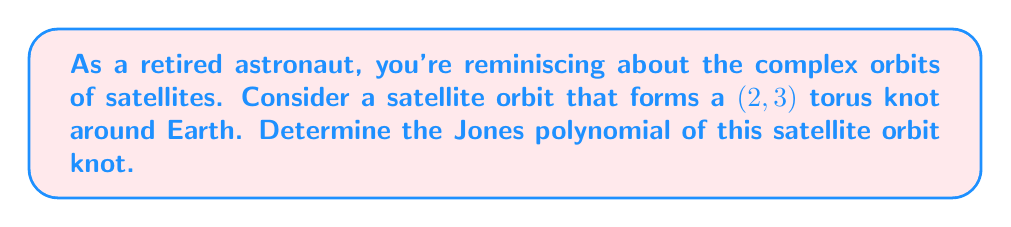Help me with this question. Let's approach this step-by-step:

1) The $(2,3)$ torus knot is also known as the trefoil knot.

2) To calculate the Jones polynomial, we'll use the skein relation:

   $$t^{-1}V(L_+) - tV(L_-) = (t^{1/2} - t^{-1/2})V(L_0)$$

   where $L_+$, $L_-$, and $L_0$ are link diagrams that are identical except at one crossing.

3) For the trefoil knot, we can use the following sequence of skein relations:

   $$V(\text{trefoil}) = t^{-1}V(\text{unknot}) - (t^{1/2} - t^{-1/2})V(\text{Hopf link})$$

4) We know that:
   - $V(\text{unknot}) = 1$
   - $V(\text{Hopf link}) = -t^{1/2} - t^{-3/2}$

5) Substituting these values:

   $$V(\text{trefoil}) = t^{-1} - (t^{1/2} - t^{-1/2})(-t^{1/2} - t^{-3/2})$$

6) Simplifying:

   $$V(\text{trefoil}) = t^{-1} + (t^{1/2} - t^{-1/2})(t^{1/2} + t^{-3/2})$$
   $$= t^{-1} + (t - t^{-1} + t^{-2} - t^{-3})$$
   $$= t + t^{-1} - t^{-3}$$

Therefore, the Jones polynomial of the satellite orbit forming a $(2,3)$ torus knot is $t + t^{-1} - t^{-3}$.
Answer: $t + t^{-1} - t^{-3}$ 